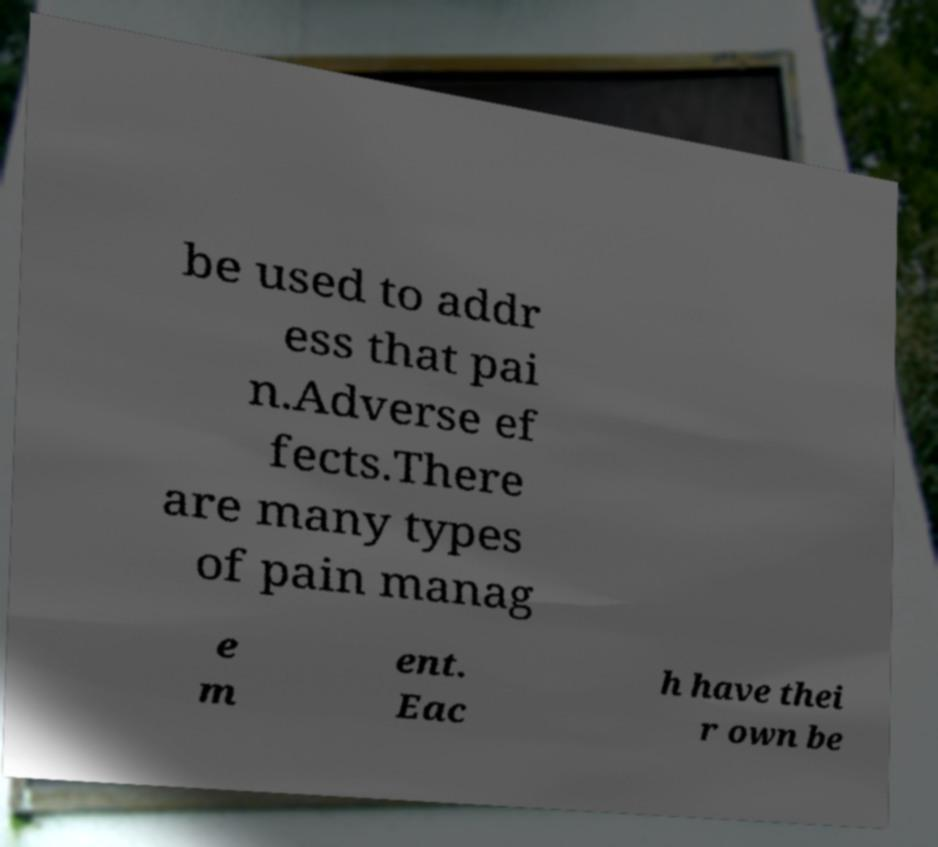There's text embedded in this image that I need extracted. Can you transcribe it verbatim? be used to addr ess that pai n.Adverse ef fects.There are many types of pain manag e m ent. Eac h have thei r own be 